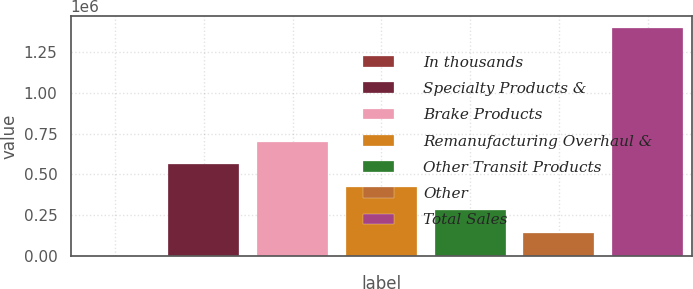<chart> <loc_0><loc_0><loc_500><loc_500><bar_chart><fcel>In thousands<fcel>Specialty Products &<fcel>Brake Products<fcel>Remanufacturing Overhaul &<fcel>Other Transit Products<fcel>Other<fcel>Total Sales<nl><fcel>2009<fcel>561852<fcel>701812<fcel>421891<fcel>281930<fcel>141970<fcel>1.40162e+06<nl></chart> 